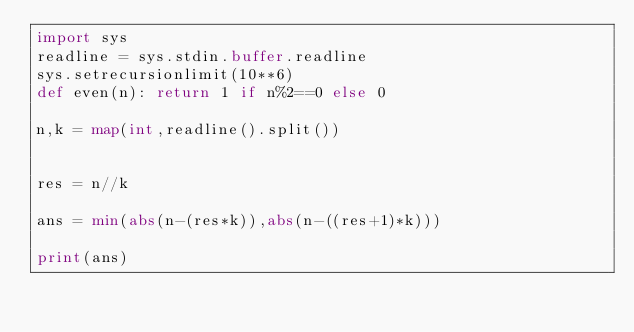Convert code to text. <code><loc_0><loc_0><loc_500><loc_500><_Python_>import sys
readline = sys.stdin.buffer.readline
sys.setrecursionlimit(10**6)
def even(n): return 1 if n%2==0 else 0

n,k = map(int,readline().split())


res = n//k

ans = min(abs(n-(res*k)),abs(n-((res+1)*k)))

print(ans)</code> 